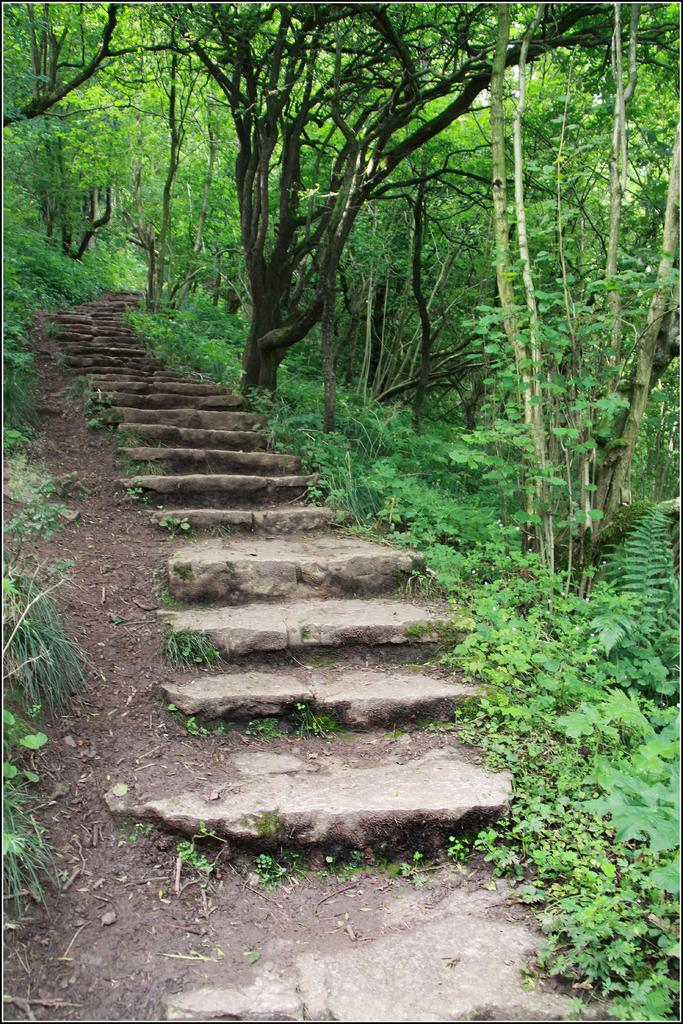What is the main feature of the image? There is a staircase with marbles in the image. What can be seen in the background of the image? There are trees in the image. Are there any other plants besides trees in the image? Yes, there are plants in the image. What type of kite is being flown by the cat in the image? There is no cat or kite present in the image. What is the purpose of the protest in the image? There is no protest present in the image. 